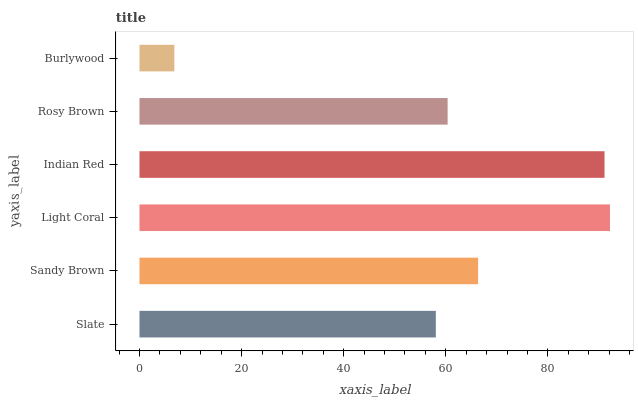Is Burlywood the minimum?
Answer yes or no. Yes. Is Light Coral the maximum?
Answer yes or no. Yes. Is Sandy Brown the minimum?
Answer yes or no. No. Is Sandy Brown the maximum?
Answer yes or no. No. Is Sandy Brown greater than Slate?
Answer yes or no. Yes. Is Slate less than Sandy Brown?
Answer yes or no. Yes. Is Slate greater than Sandy Brown?
Answer yes or no. No. Is Sandy Brown less than Slate?
Answer yes or no. No. Is Sandy Brown the high median?
Answer yes or no. Yes. Is Rosy Brown the low median?
Answer yes or no. Yes. Is Slate the high median?
Answer yes or no. No. Is Slate the low median?
Answer yes or no. No. 